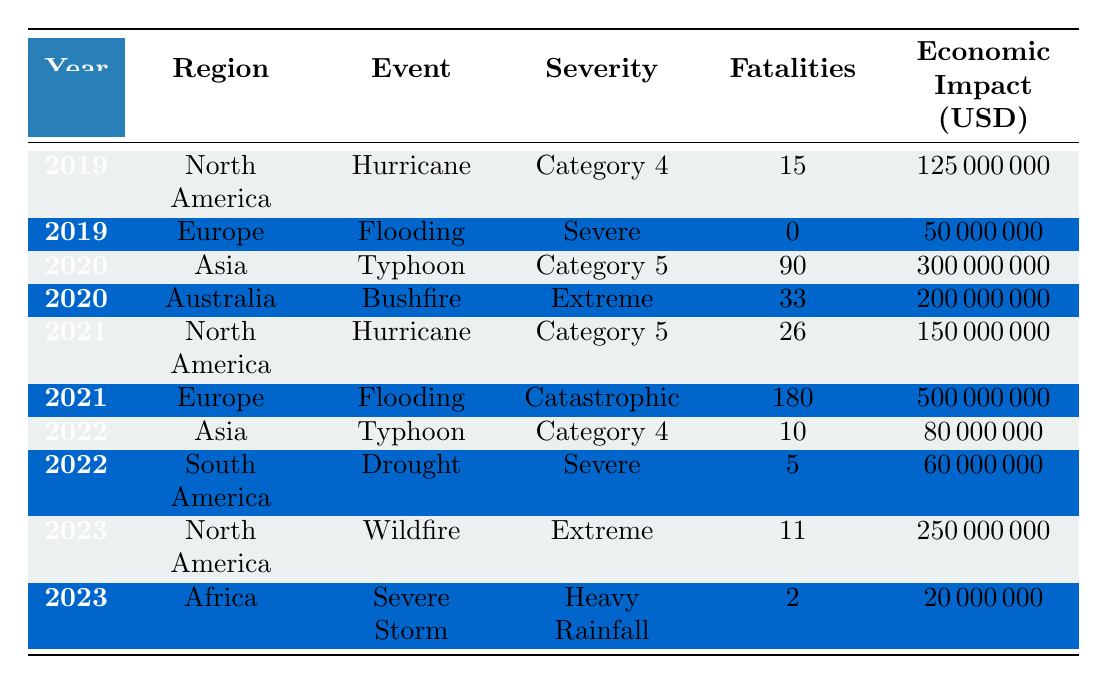What extreme weather event caused the most fatalities between 2019 and 2023? Looking through the table, I identify the fatality counts: Hurricane in 2019 had 15, Flooding in 2019 had 0, Typhoon in 2020 had 90, Bushfire in 2020 had 33, Hurricane in 2021 had 26, Flooding in 2021 had 180, Typhoon in 2022 had 10, Drought in 2022 had 5, Wildfire in 2023 had 11, and Severe Storm in 2023 had 2. The highest is the Flooding in 2021 with 180 fatalities.
Answer: 180 What was the total economic impact of the extreme weather events in North America during this period? I look for all entries in North America: Hurricane in 2019 had an economic impact of 125 million, Hurricane in 2021, 150 million, and Wildfire in 2023, 250 million. Summing these gives 125 + 150 + 250 = 525 million USD.
Answer: 525 million Did any extreme weather event in South America result in fatalities? I examine the South America entry: Drought in São Paulo, Brazil in 2022 shows 5 fatalities. Therefore, the answer is yes, there were fatalities.
Answer: Yes Which region experienced the highest economic impact from extreme weather events, and what was the amount? I analyze the economic impacts from each region: North America totals 525 million, Europe in 2021 total 500 million, Asia in 2020 total 300 million, Australia 200 million, and South America 60 million. The highest is 525 million USD from North America.
Answer: North America, 525 million What is the average number of fatalities across all extreme weather events from 2019 to 2023? Total fatalities are: 15 + 0 + 90 + 33 + 26 + 180 + 10 + 5 + 11 + 2 = 372. There are 10 events, so the average is 372 / 10 = 37.2.
Answer: 37.2 